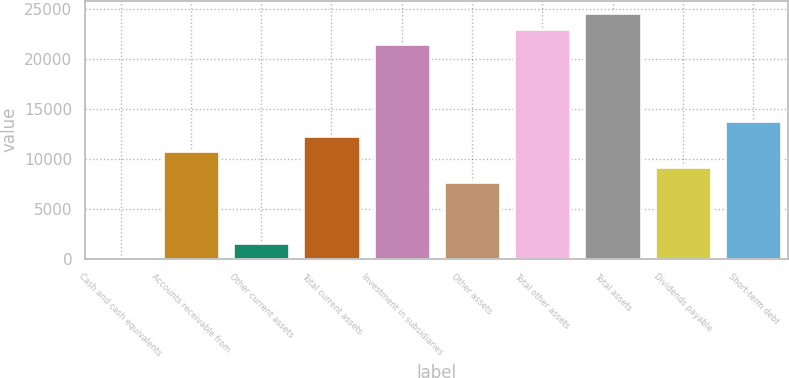Convert chart to OTSL. <chart><loc_0><loc_0><loc_500><loc_500><bar_chart><fcel>Cash and cash equivalents<fcel>Accounts receivable from<fcel>Other current assets<fcel>Total current assets<fcel>Investment in subsidiaries<fcel>Other assets<fcel>Total other assets<fcel>Total assets<fcel>Dividends payable<fcel>Short-term debt<nl><fcel>1<fcel>10737.6<fcel>1534.8<fcel>12271.4<fcel>21474.2<fcel>7670<fcel>23008<fcel>24541.8<fcel>9203.8<fcel>13805.2<nl></chart> 